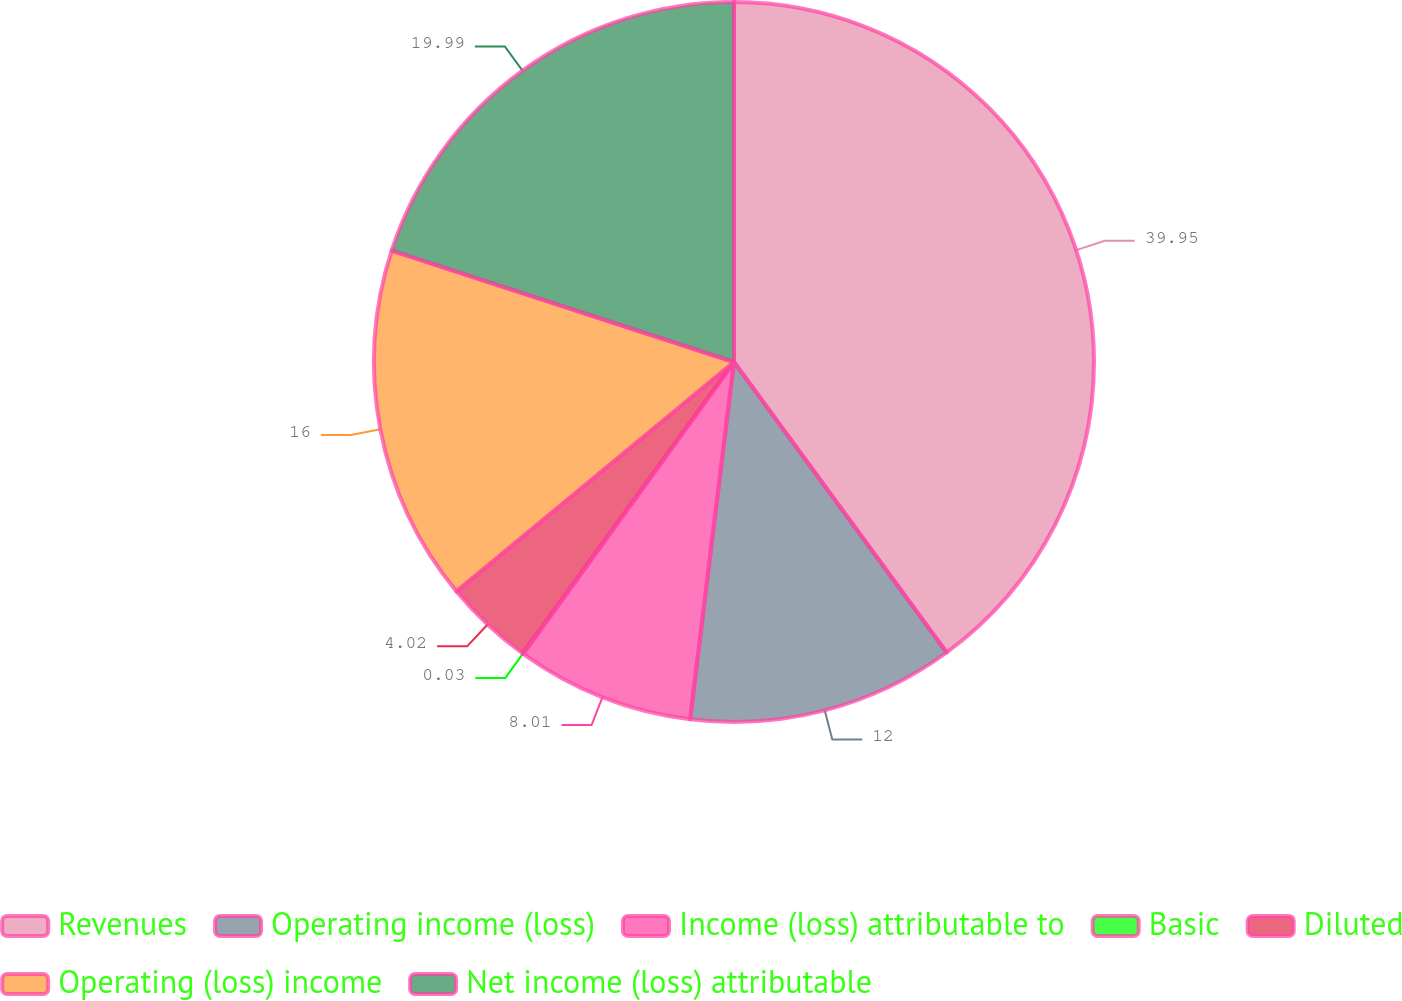Convert chart to OTSL. <chart><loc_0><loc_0><loc_500><loc_500><pie_chart><fcel>Revenues<fcel>Operating income (loss)<fcel>Income (loss) attributable to<fcel>Basic<fcel>Diluted<fcel>Operating (loss) income<fcel>Net income (loss) attributable<nl><fcel>39.94%<fcel>12.0%<fcel>8.01%<fcel>0.03%<fcel>4.02%<fcel>16.0%<fcel>19.99%<nl></chart> 